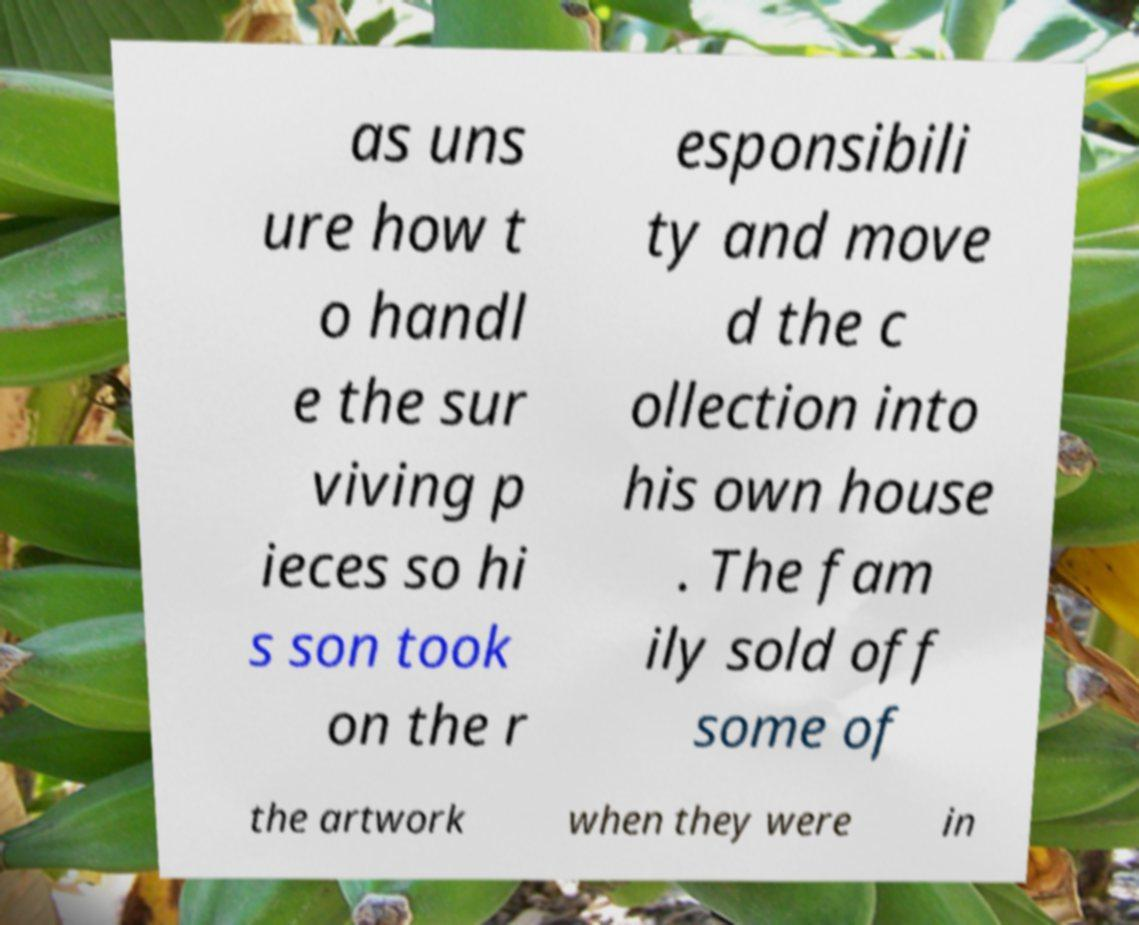Please read and relay the text visible in this image. What does it say? as uns ure how t o handl e the sur viving p ieces so hi s son took on the r esponsibili ty and move d the c ollection into his own house . The fam ily sold off some of the artwork when they were in 